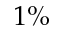<formula> <loc_0><loc_0><loc_500><loc_500>1 \%</formula> 